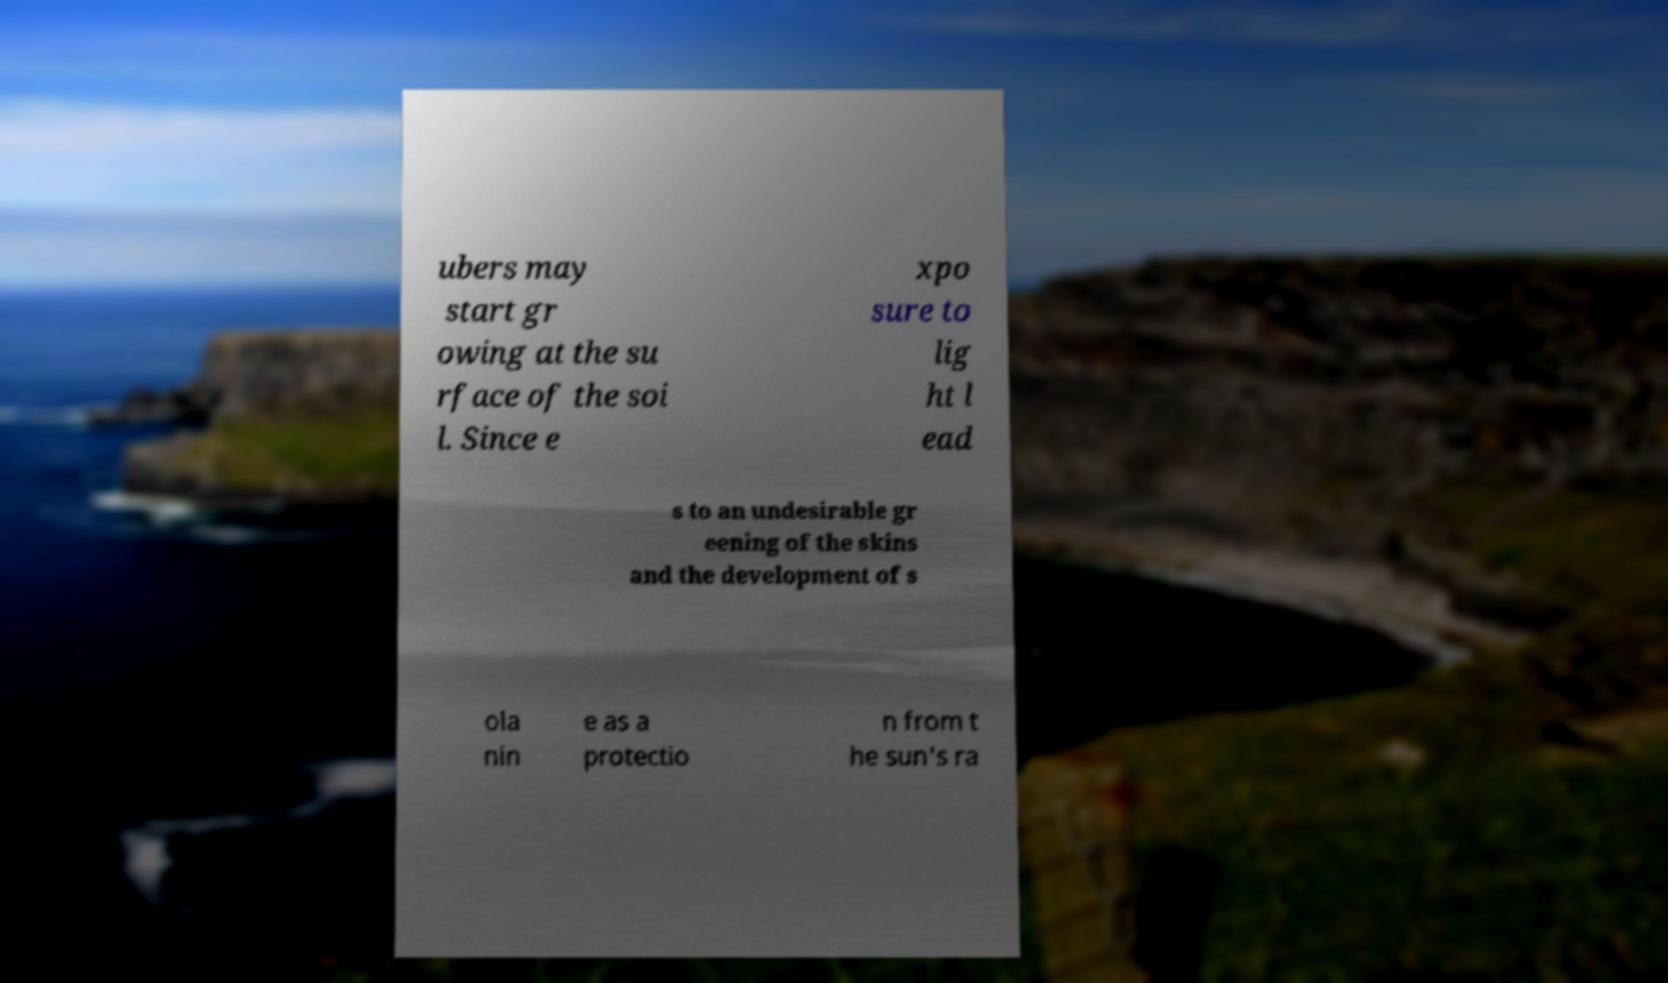Please read and relay the text visible in this image. What does it say? ubers may start gr owing at the su rface of the soi l. Since e xpo sure to lig ht l ead s to an undesirable gr eening of the skins and the development of s ola nin e as a protectio n from t he sun's ra 